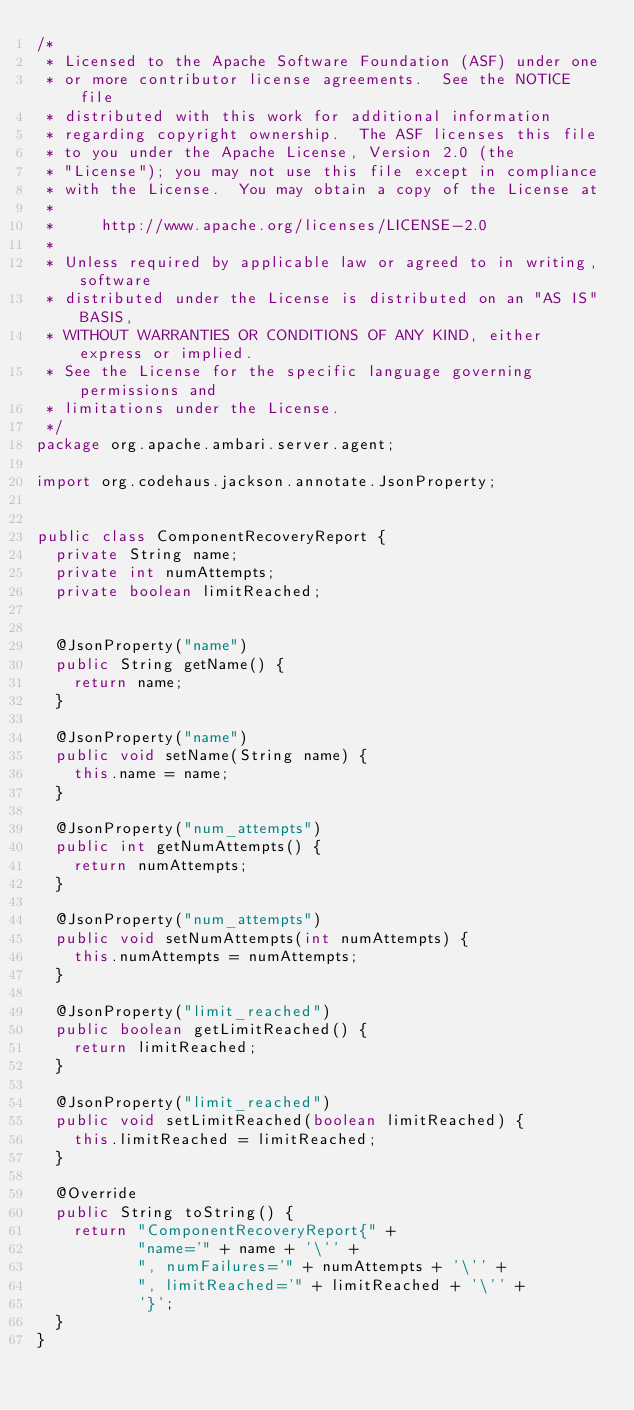<code> <loc_0><loc_0><loc_500><loc_500><_Java_>/*
 * Licensed to the Apache Software Foundation (ASF) under one
 * or more contributor license agreements.  See the NOTICE file
 * distributed with this work for additional information
 * regarding copyright ownership.  The ASF licenses this file
 * to you under the Apache License, Version 2.0 (the
 * "License"); you may not use this file except in compliance
 * with the License.  You may obtain a copy of the License at
 *
 *     http://www.apache.org/licenses/LICENSE-2.0
 *
 * Unless required by applicable law or agreed to in writing, software
 * distributed under the License is distributed on an "AS IS" BASIS,
 * WITHOUT WARRANTIES OR CONDITIONS OF ANY KIND, either express or implied.
 * See the License for the specific language governing permissions and
 * limitations under the License.
 */
package org.apache.ambari.server.agent;

import org.codehaus.jackson.annotate.JsonProperty;


public class ComponentRecoveryReport {
  private String name;
  private int numAttempts;
  private boolean limitReached;


  @JsonProperty("name")
  public String getName() {
    return name;
  }

  @JsonProperty("name")
  public void setName(String name) {
    this.name = name;
  }

  @JsonProperty("num_attempts")
  public int getNumAttempts() {
    return numAttempts;
  }

  @JsonProperty("num_attempts")
  public void setNumAttempts(int numAttempts) {
    this.numAttempts = numAttempts;
  }

  @JsonProperty("limit_reached")
  public boolean getLimitReached() {
    return limitReached;
  }

  @JsonProperty("limit_reached")
  public void setLimitReached(boolean limitReached) {
    this.limitReached = limitReached;
  }

  @Override
  public String toString() {
    return "ComponentRecoveryReport{" +
           "name='" + name + '\'' +
           ", numFailures='" + numAttempts + '\'' +
           ", limitReached='" + limitReached + '\'' +
           '}';
  }
}
</code> 